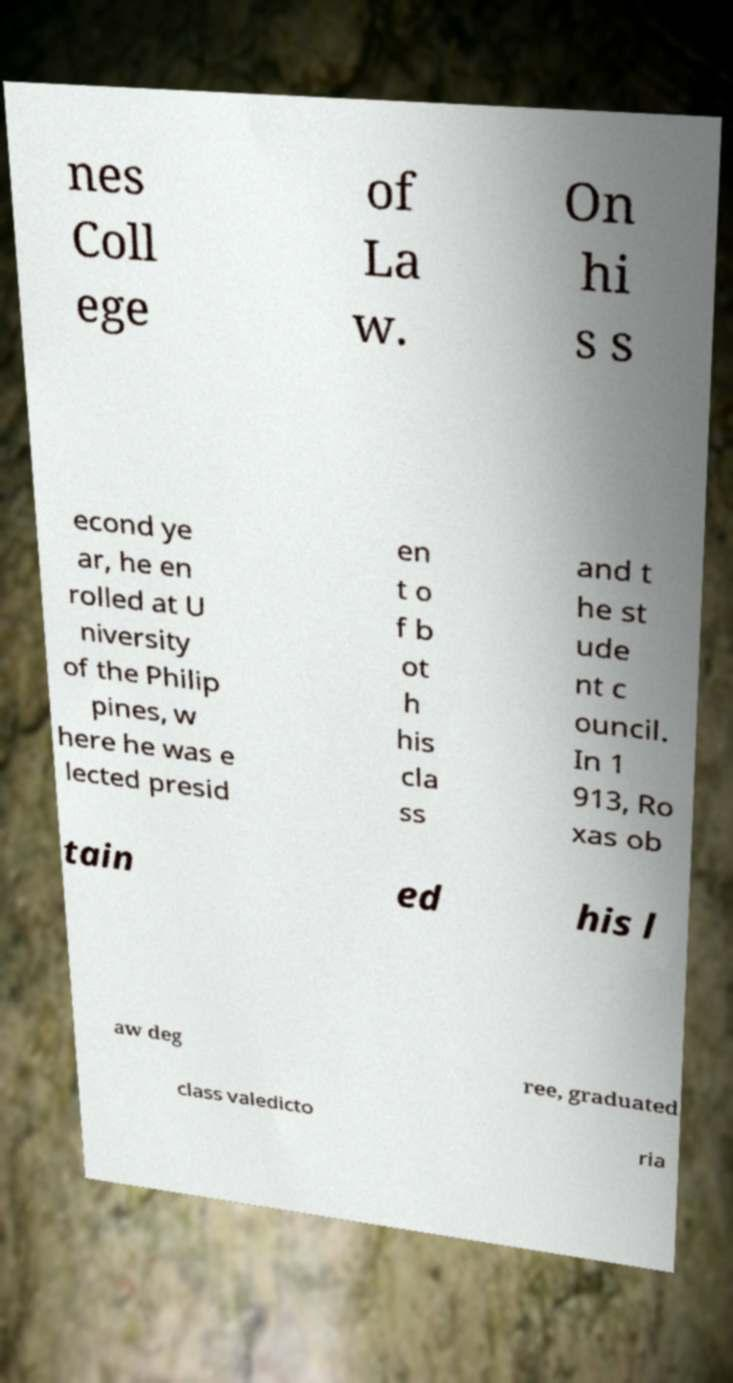Can you accurately transcribe the text from the provided image for me? nes Coll ege of La w. On hi s s econd ye ar, he en rolled at U niversity of the Philip pines, w here he was e lected presid en t o f b ot h his cla ss and t he st ude nt c ouncil. In 1 913, Ro xas ob tain ed his l aw deg ree, graduated class valedicto ria 